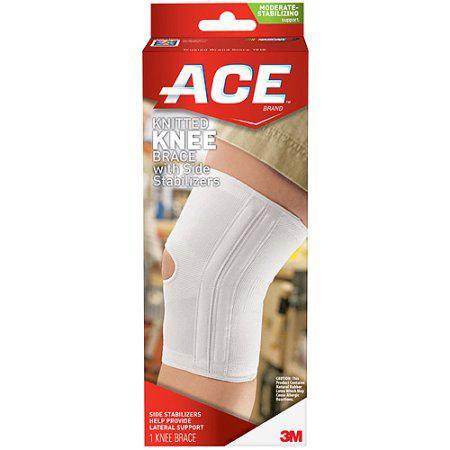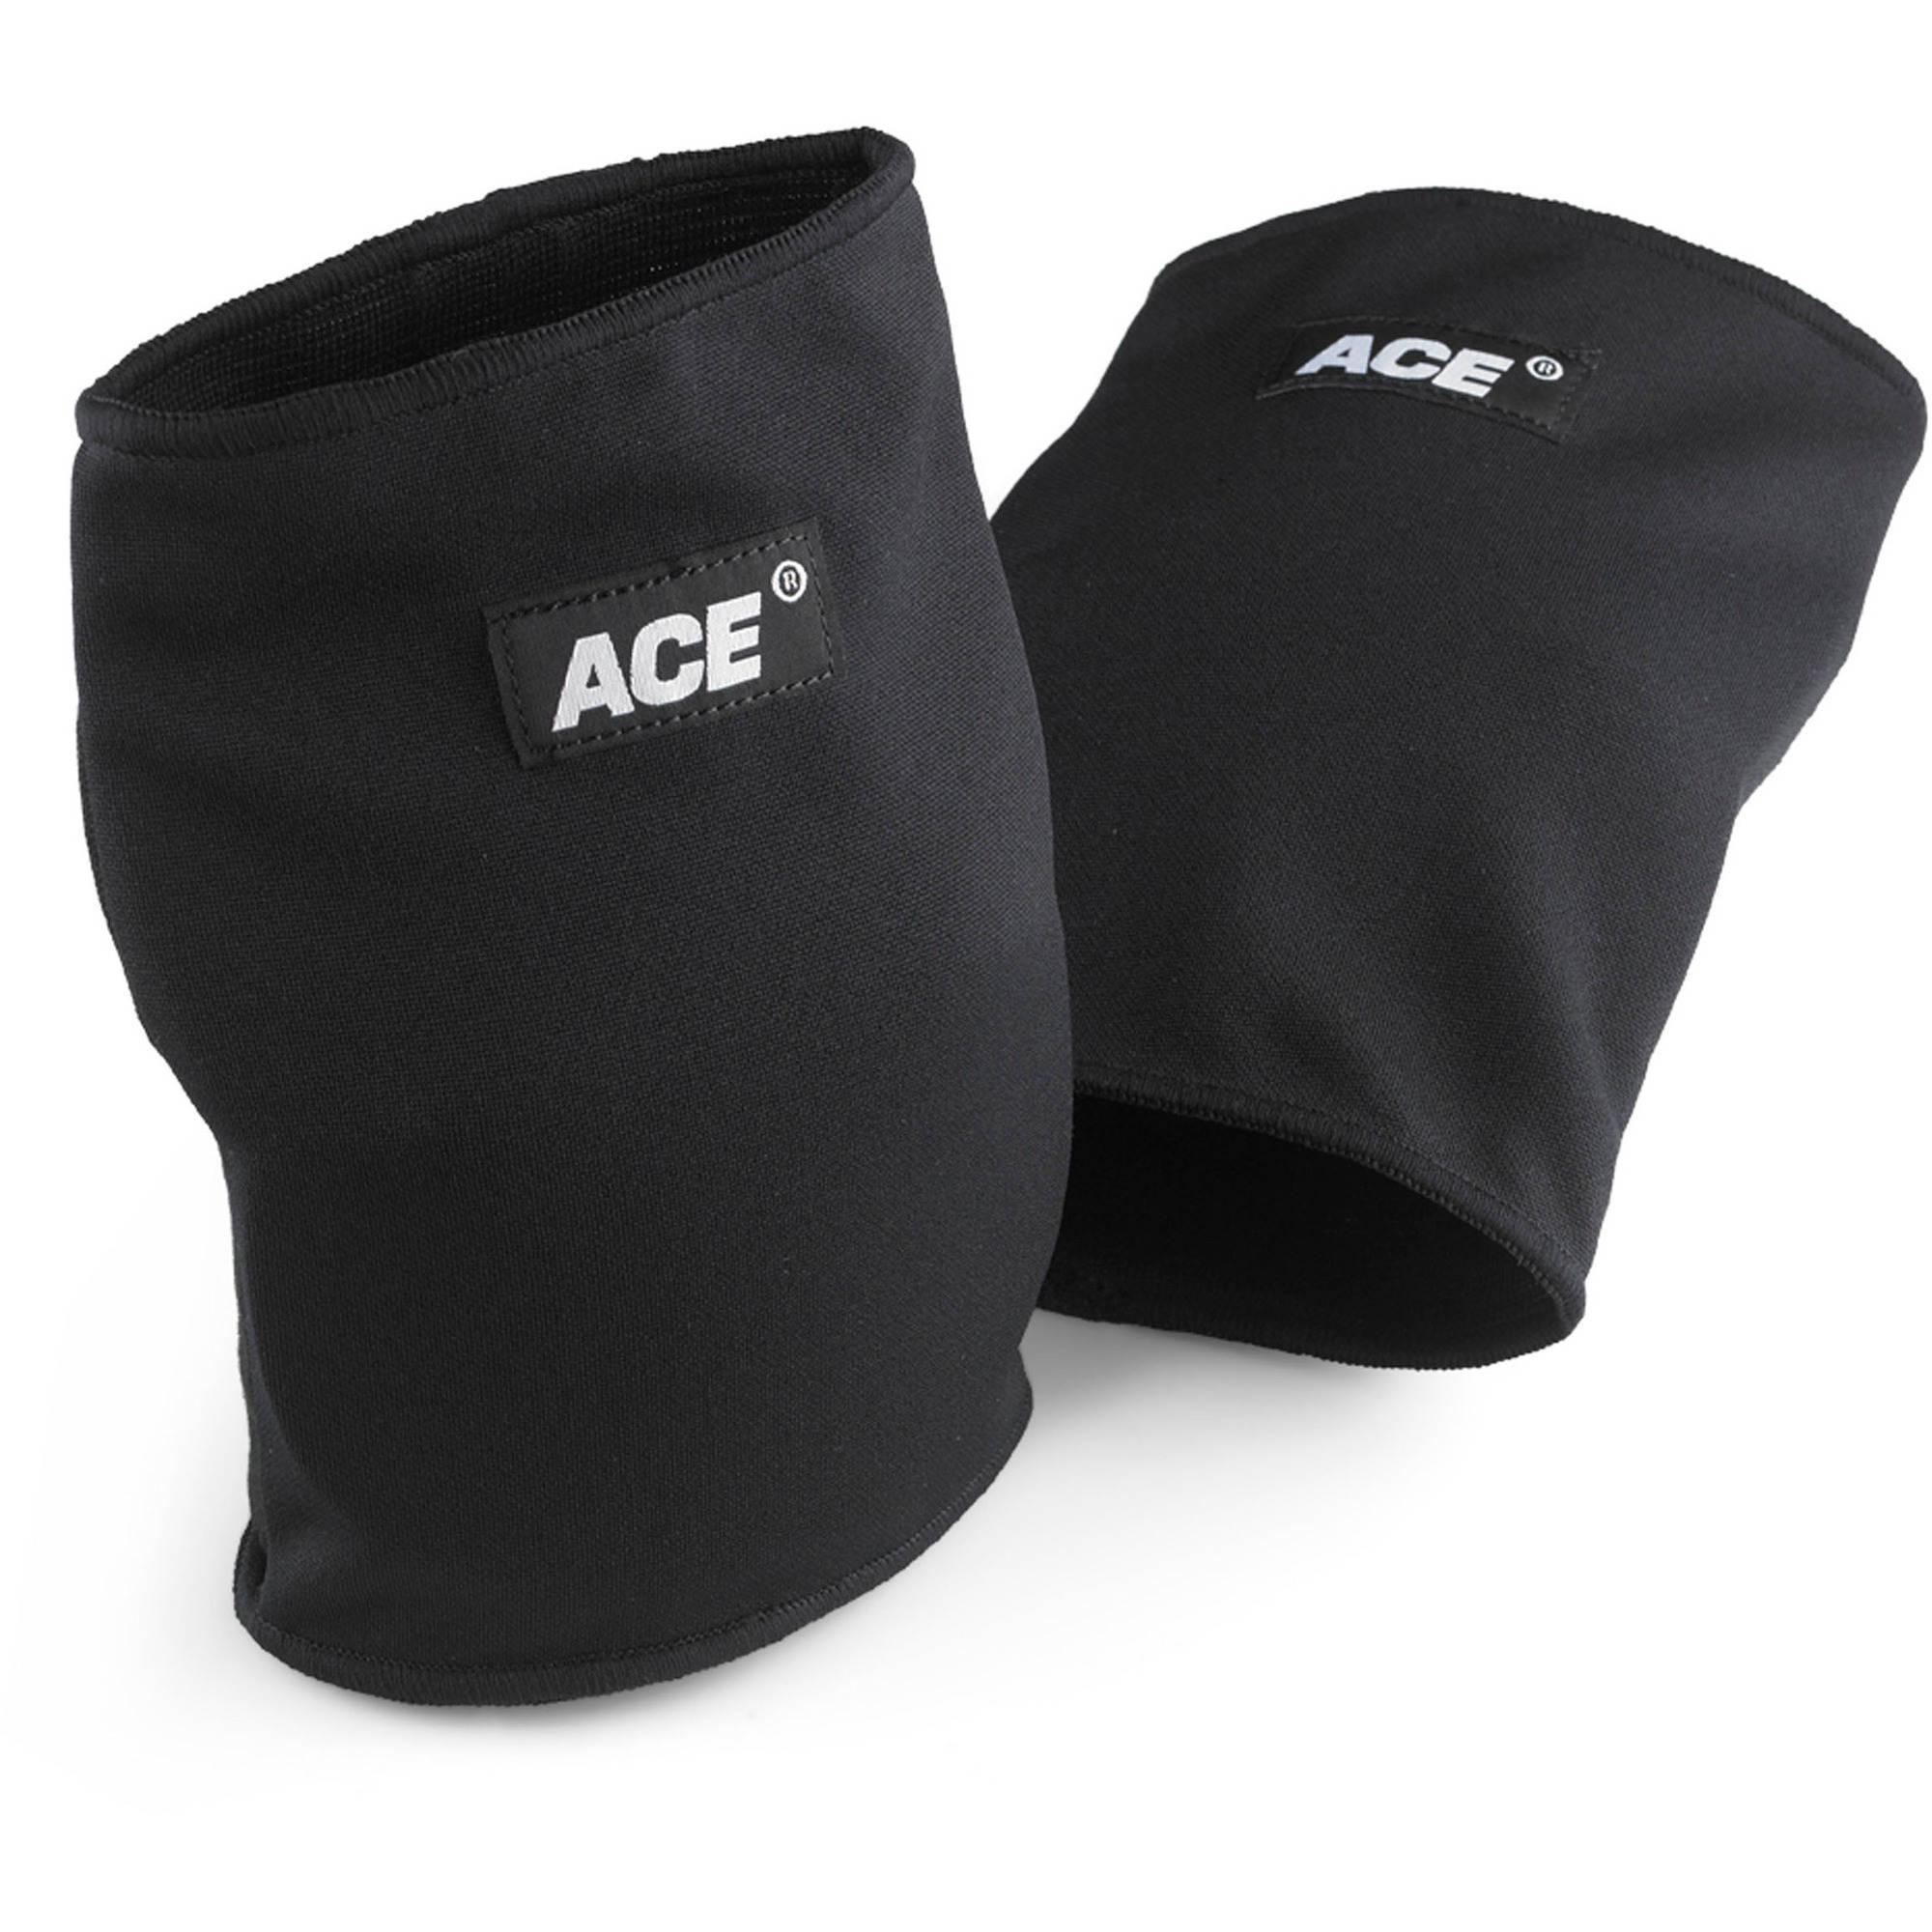The first image is the image on the left, the second image is the image on the right. Evaluate the accuracy of this statement regarding the images: "One of the images shows exactly two knee braces.". Is it true? Answer yes or no. Yes. The first image is the image on the left, the second image is the image on the right. Evaluate the accuracy of this statement regarding the images: "One of the images features a knee pad still in its red packaging". Is it true? Answer yes or no. Yes. 